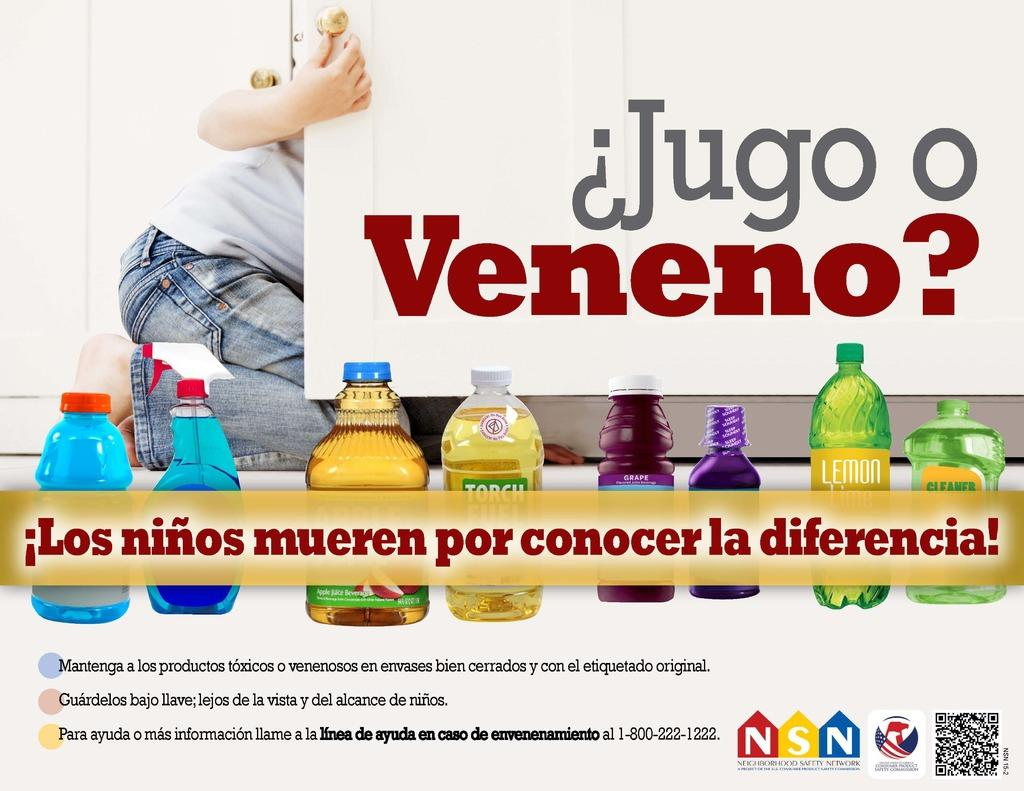What is the person in the image doing? The person is sitting on the floor in the image. What else can be seen in the image besides the person? There are bottles visible in the image. How many fish are swimming in the front of the image? There are no fish present in the image. What type of record is being played in the background of the image? There is no record being played in the image; it only features a person sitting on the floor and bottles. 